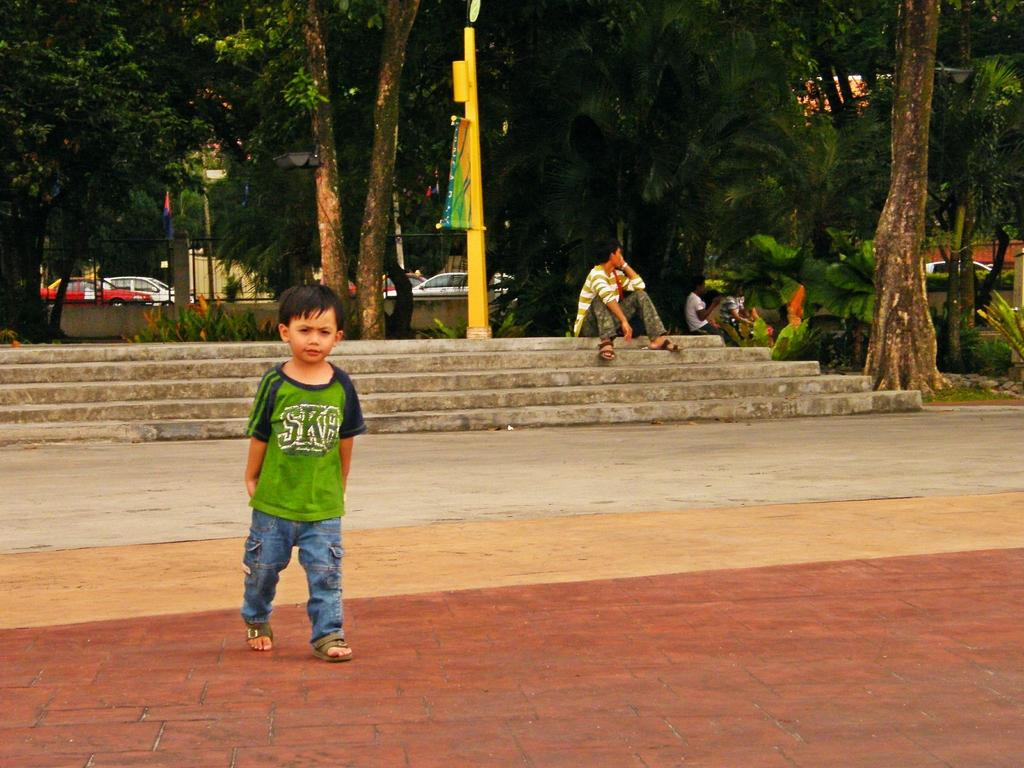What can be seen in the background of the image? In the background of the image, there are trees, a flag, a fence, and vehicles. What celestial bodies are visible in the image? Planets are visible in the image. What type of structure is present in the image? There is a pole and a banner in the image. What is the boy in the image doing? A boy is walking on the floor in the image. Are there any architectural features in the image? Yes, there are stairs in the image. What type of property does the boy own in the image? There is no indication of the boy owning any property in the image. What is the boy using to brush his teeth in the image? There is no mouth or toothbrush visible in the image. Where is the cellar located in the image? There is no mention of a cellar in the image. 